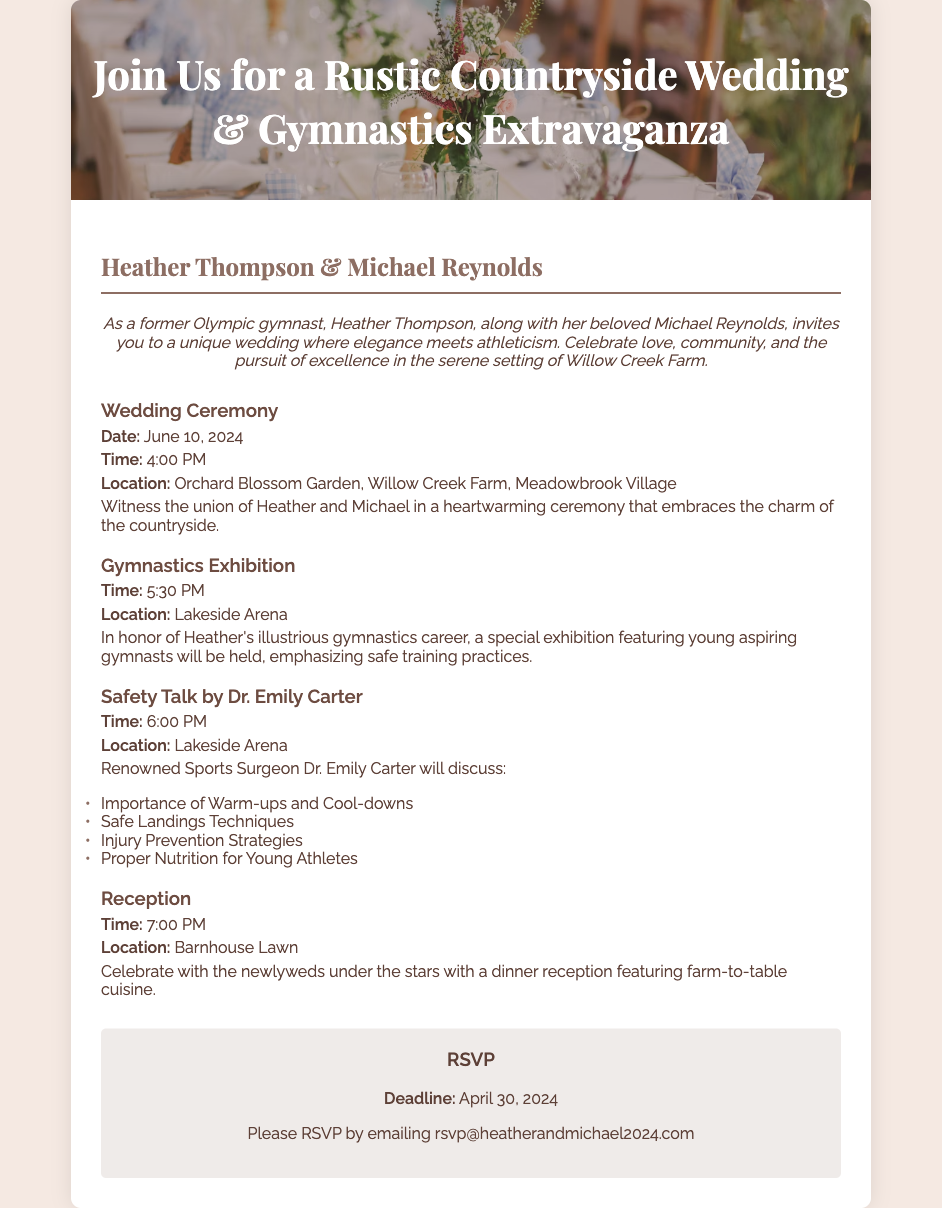What is the date of the wedding? The wedding date is explicitly mentioned in the document as June 10, 2024.
Answer: June 10, 2024 What is the location of the wedding ceremony? The document states that the wedding ceremony will take place at Orchard Blossom Garden, Willow Creek Farm, Meadowbrook Village.
Answer: Orchard Blossom Garden, Willow Creek Farm, Meadowbrook Village Who will give the safety talk? The document mentions that Dr. Emily Carter will be discussing safety practices during the event.
Answer: Dr. Emily Carter What time does the Gymnastics Exhibition start? The starting time for the Gymnastics Exhibition is specified as 5:30 PM.
Answer: 5:30 PM List one topic that will be covered in the safety talk. The document lists specific topics; one of them is "Importance of Warm-ups and Cool-downs."
Answer: Importance of Warm-ups and Cool-downs What is the RSVP deadline? The RSVP deadline is provided in the document, which is April 30, 2024.
Answer: April 30, 2024 What will be served at the reception? The document specifies that the reception will feature farm-to-table cuisine.
Answer: Farm-to-table cuisine What is the main theme of the wedding invitation? The document emphasizes a combination of love and athleticism, noting a unique wedding theme that integrates gymnastics.
Answer: Rustic Countryside Wedding & Gymnastics Extravaganza 